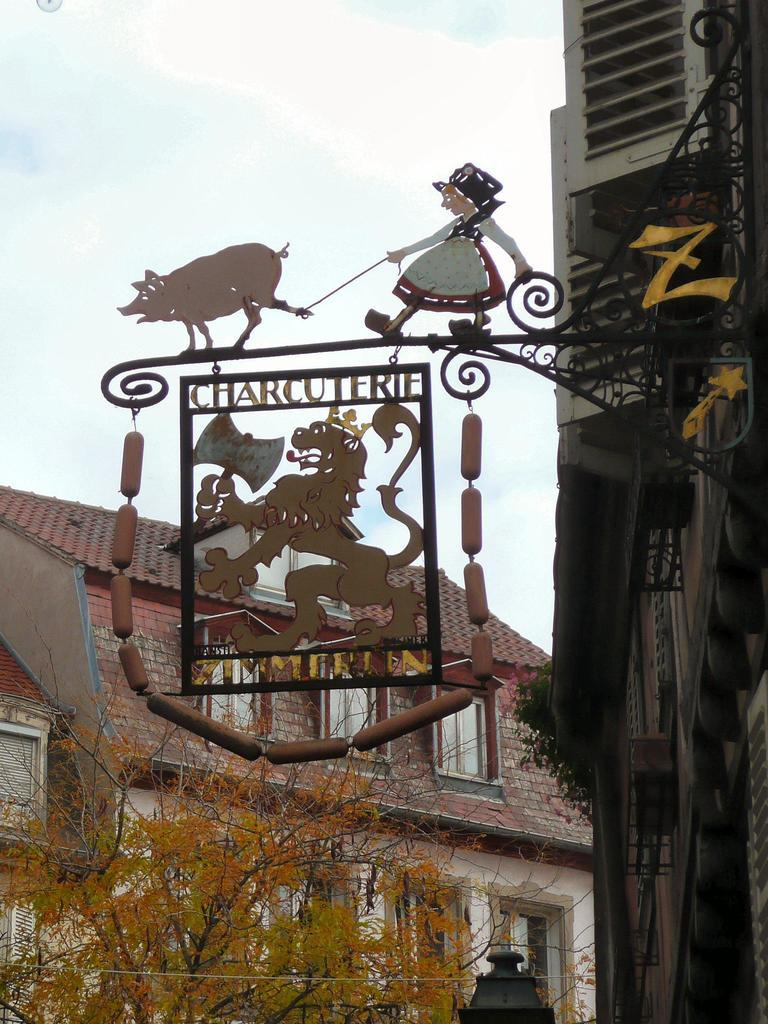What is the main object in the image? There is a name board in the image. How is the name board attached? The name board is attached to an iron grille. What other structures can be seen in the image? There are buildings in the image. What type of vegetation is present in the image? There are trees in the image. What is visible in the background of the image? The sky is visible in the background of the image. What type of vest is the tree wearing in the image? There are no vests present in the image, as trees do not wear clothing. 